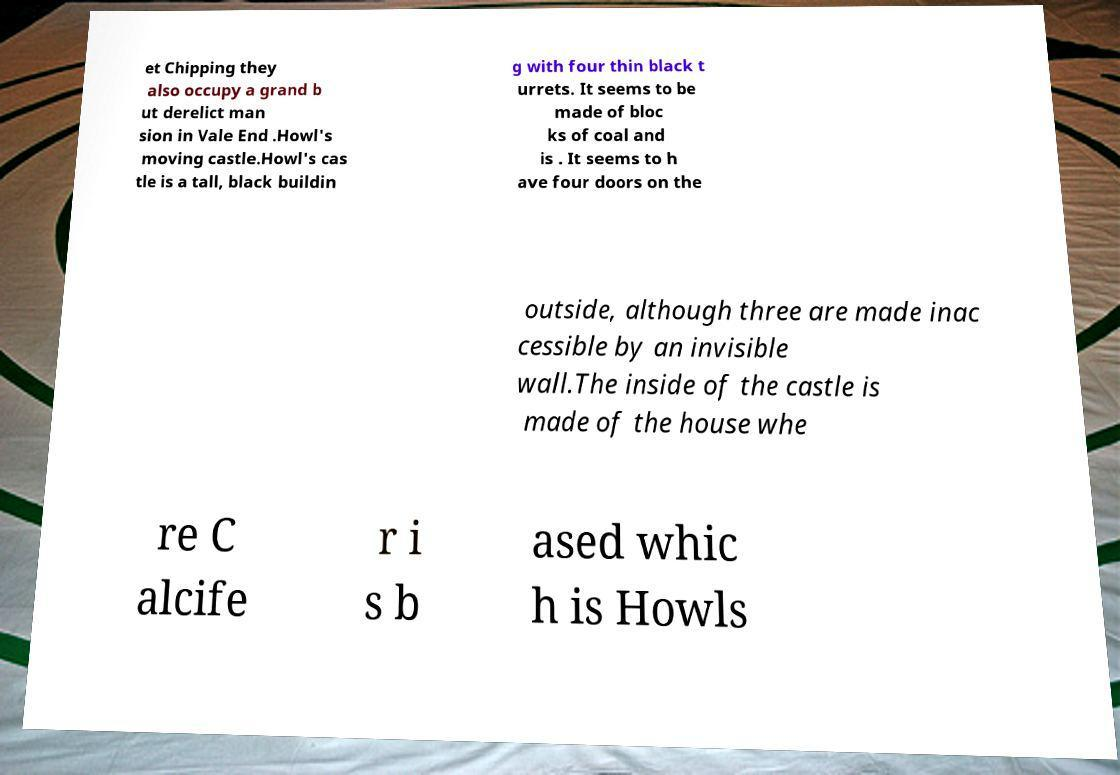Can you accurately transcribe the text from the provided image for me? et Chipping they also occupy a grand b ut derelict man sion in Vale End .Howl's moving castle.Howl's cas tle is a tall, black buildin g with four thin black t urrets. It seems to be made of bloc ks of coal and is . It seems to h ave four doors on the outside, although three are made inac cessible by an invisible wall.The inside of the castle is made of the house whe re C alcife r i s b ased whic h is Howls 